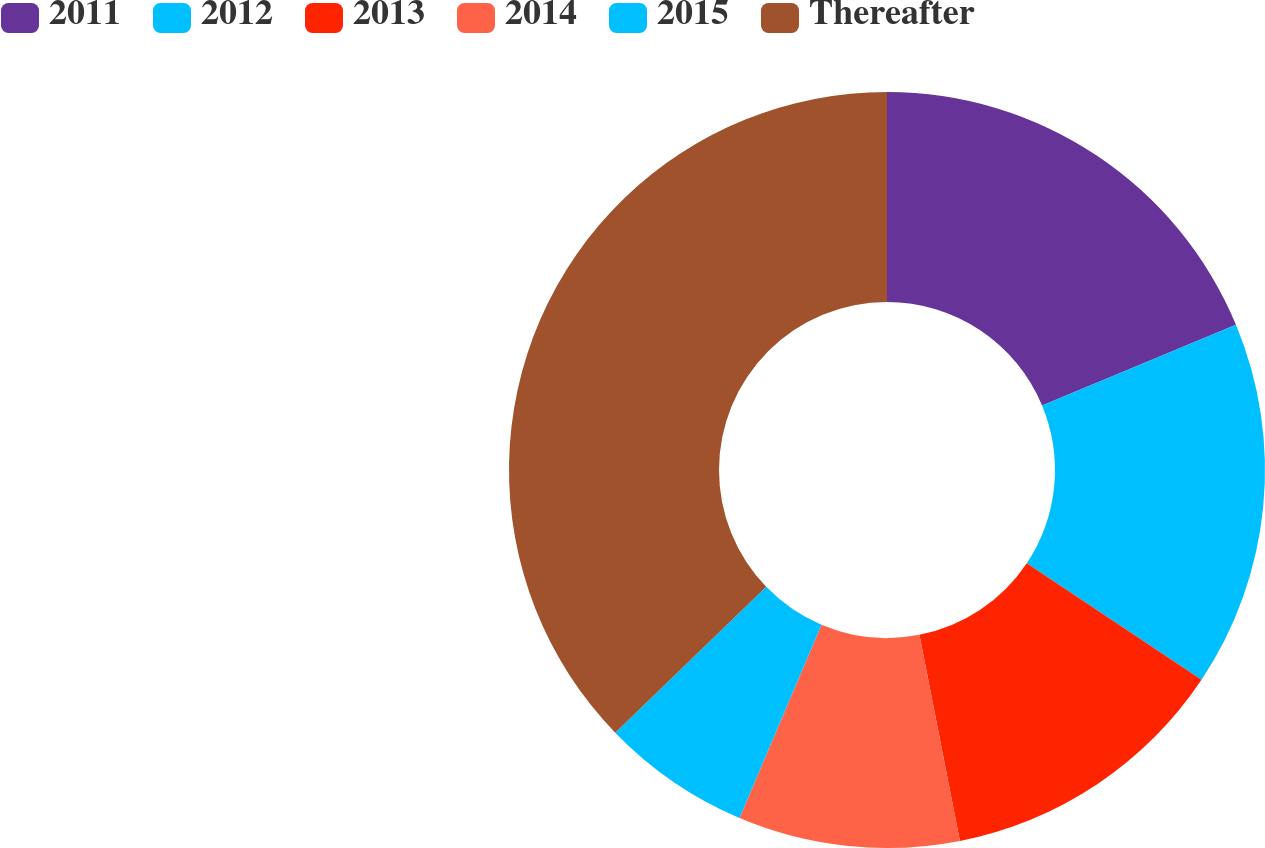Convert chart to OTSL. <chart><loc_0><loc_0><loc_500><loc_500><pie_chart><fcel>2011<fcel>2012<fcel>2013<fcel>2014<fcel>2015<fcel>Thereafter<nl><fcel>18.72%<fcel>15.64%<fcel>12.55%<fcel>9.47%<fcel>6.39%<fcel>37.23%<nl></chart> 